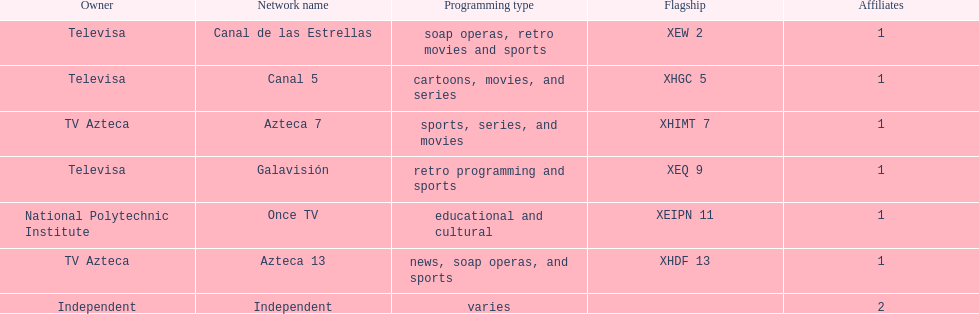What is the difference between the number of affiliates galavision has and the number of affiliates azteca 13 has? 0. 